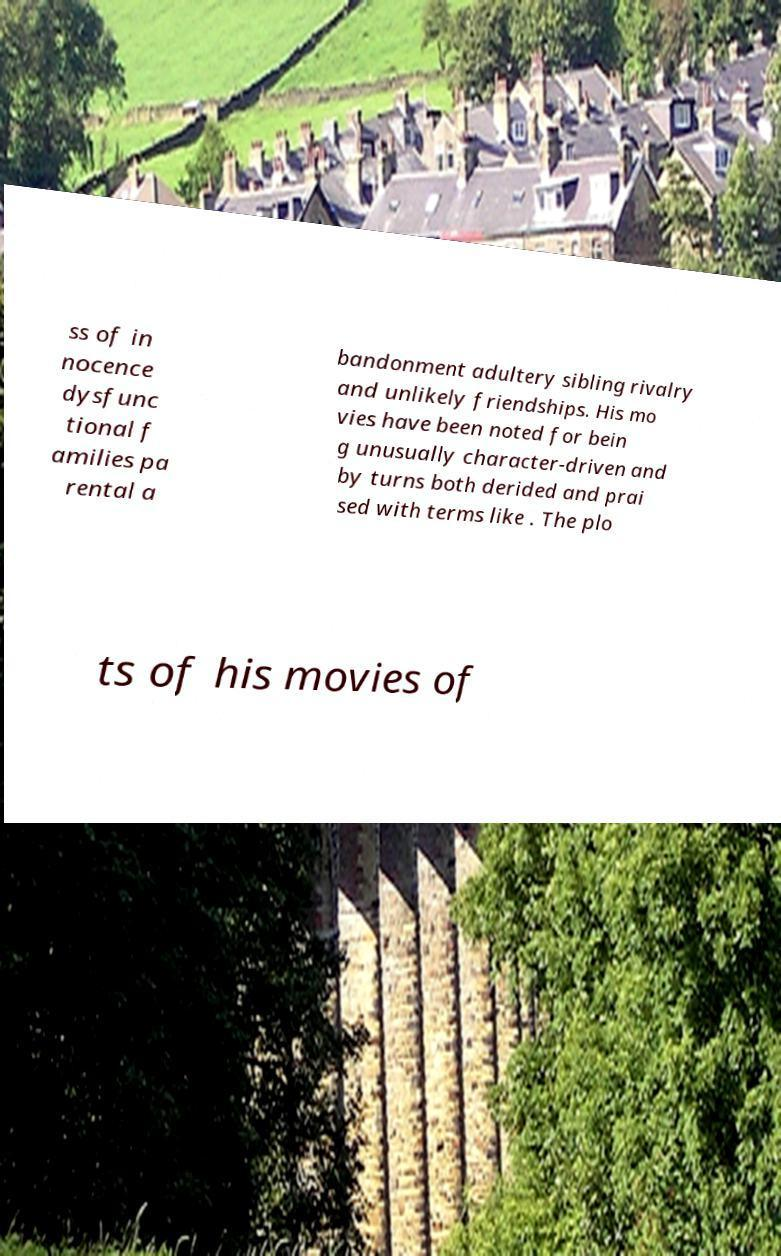Could you extract and type out the text from this image? ss of in nocence dysfunc tional f amilies pa rental a bandonment adultery sibling rivalry and unlikely friendships. His mo vies have been noted for bein g unusually character-driven and by turns both derided and prai sed with terms like . The plo ts of his movies of 